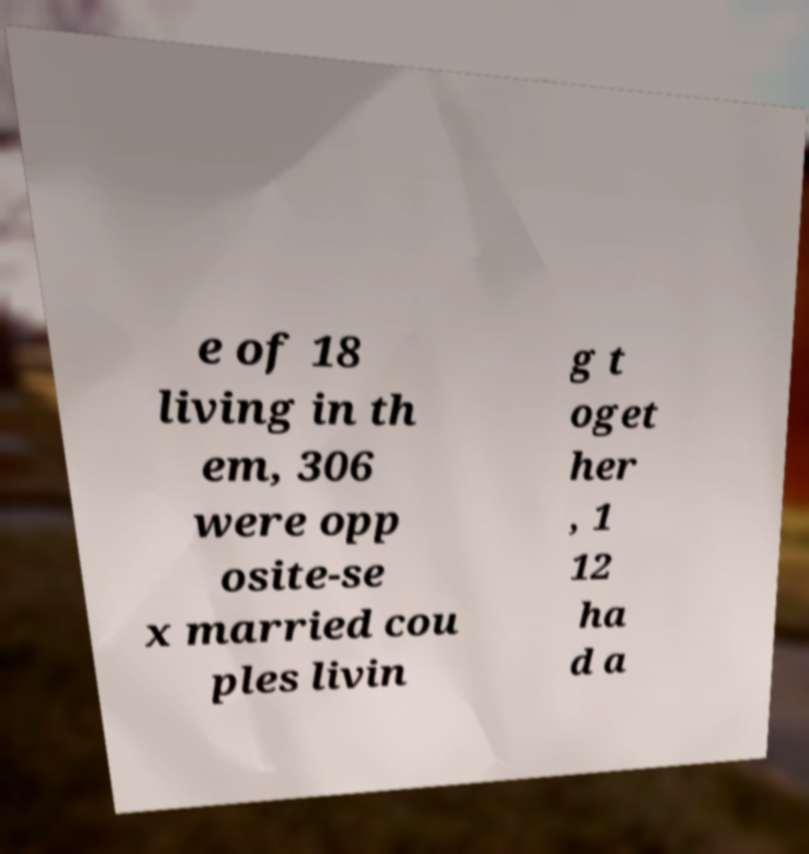For documentation purposes, I need the text within this image transcribed. Could you provide that? e of 18 living in th em, 306 were opp osite-se x married cou ples livin g t oget her , 1 12 ha d a 